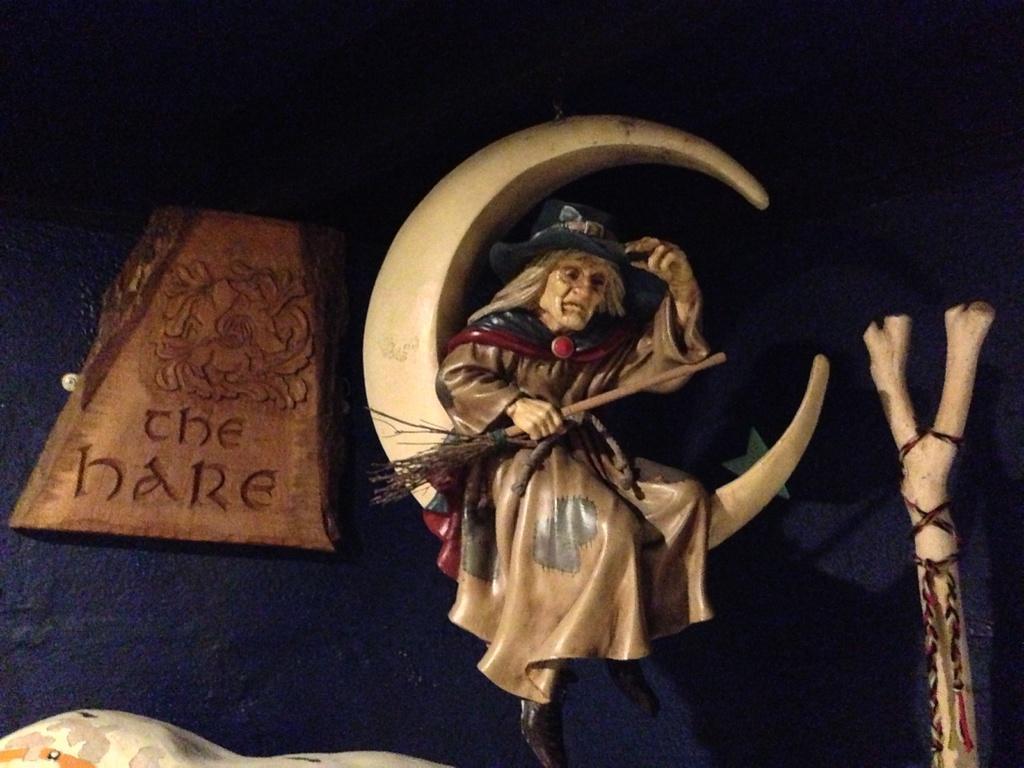Can you describe this image briefly? In this picture we can see a statue, board and objects. In the background of the image it is dark. 